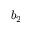<formula> <loc_0><loc_0><loc_500><loc_500>b _ { 2 }</formula> 